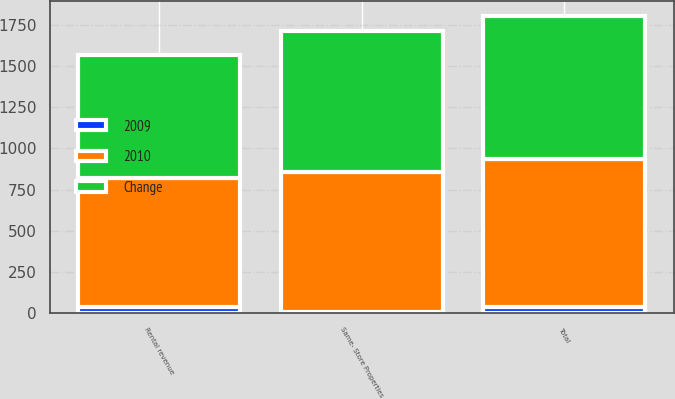Convert chart to OTSL. <chart><loc_0><loc_0><loc_500><loc_500><stacked_bar_chart><ecel><fcel>Rental revenue<fcel>Total<fcel>Same- Store Properties<nl><fcel>2010<fcel>782.5<fcel>900.7<fcel>855.3<nl><fcel>Change<fcel>746.6<fcel>865.6<fcel>851.4<nl><fcel>2009<fcel>35.9<fcel>35.1<fcel>3.9<nl></chart> 